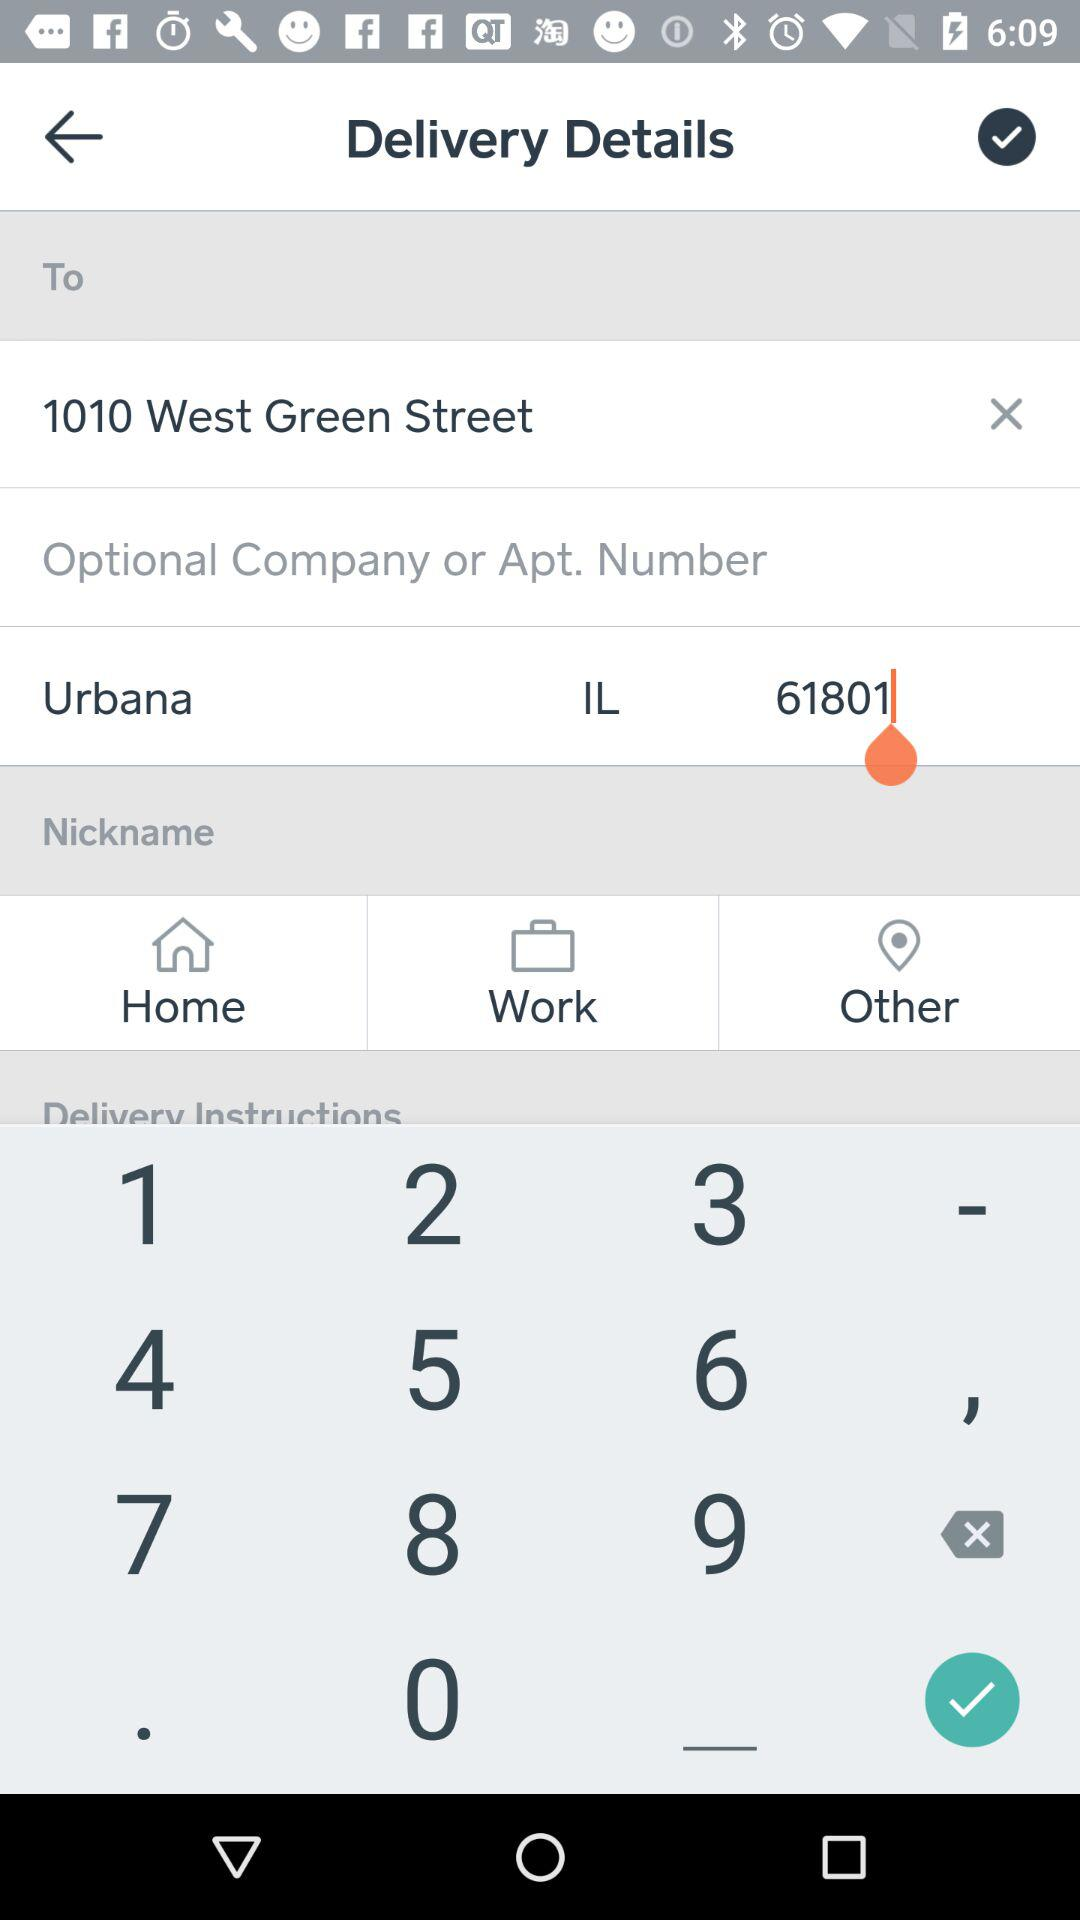What are the delivery instructions?
When the provided information is insufficient, respond with <no answer>. <no answer> 